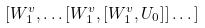<formula> <loc_0><loc_0><loc_500><loc_500>[ W ^ { v } _ { 1 } , \dots [ W _ { 1 } ^ { v } , [ W _ { 1 } ^ { v } , U _ { 0 } ] ] \dots ]</formula> 